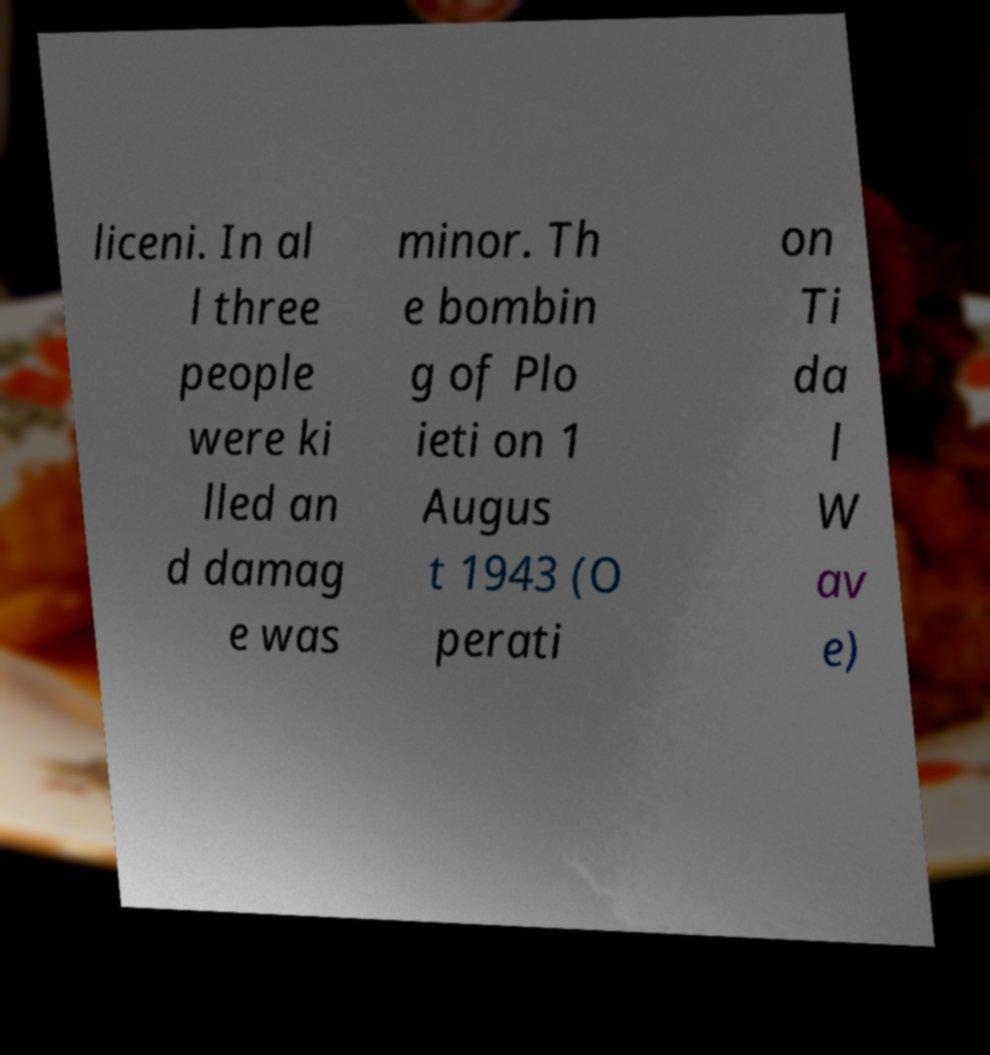I need the written content from this picture converted into text. Can you do that? liceni. In al l three people were ki lled an d damag e was minor. Th e bombin g of Plo ieti on 1 Augus t 1943 (O perati on Ti da l W av e) 